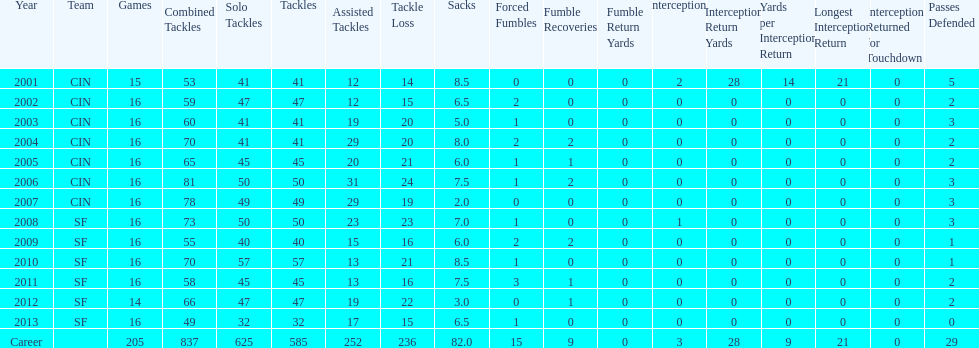How many fumble recoveries did this player have in 2004? 2. 